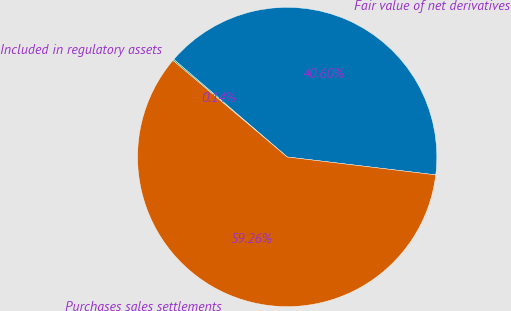Convert chart to OTSL. <chart><loc_0><loc_0><loc_500><loc_500><pie_chart><fcel>Fair value of net derivatives<fcel>Included in regulatory assets<fcel>Purchases sales settlements<nl><fcel>40.6%<fcel>0.14%<fcel>59.26%<nl></chart> 